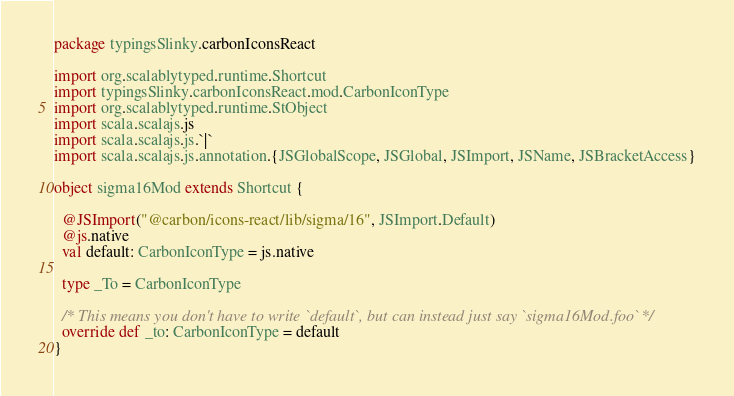Convert code to text. <code><loc_0><loc_0><loc_500><loc_500><_Scala_>package typingsSlinky.carbonIconsReact

import org.scalablytyped.runtime.Shortcut
import typingsSlinky.carbonIconsReact.mod.CarbonIconType
import org.scalablytyped.runtime.StObject
import scala.scalajs.js
import scala.scalajs.js.`|`
import scala.scalajs.js.annotation.{JSGlobalScope, JSGlobal, JSImport, JSName, JSBracketAccess}

object sigma16Mod extends Shortcut {
  
  @JSImport("@carbon/icons-react/lib/sigma/16", JSImport.Default)
  @js.native
  val default: CarbonIconType = js.native
  
  type _To = CarbonIconType
  
  /* This means you don't have to write `default`, but can instead just say `sigma16Mod.foo` */
  override def _to: CarbonIconType = default
}
</code> 